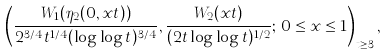Convert formula to latex. <formula><loc_0><loc_0><loc_500><loc_500>\left ( \frac { W _ { 1 } ( \eta _ { 2 } ( 0 , x t ) ) } { 2 ^ { 3 / 4 } t ^ { 1 / 4 } ( \log \log t ) ^ { 3 / 4 } } , \frac { W _ { 2 } ( x t ) } { ( 2 t \log \log t ) ^ { 1 / 2 } } ; \, 0 \leq x \leq 1 \right ) _ { t \geq 3 } ,</formula> 